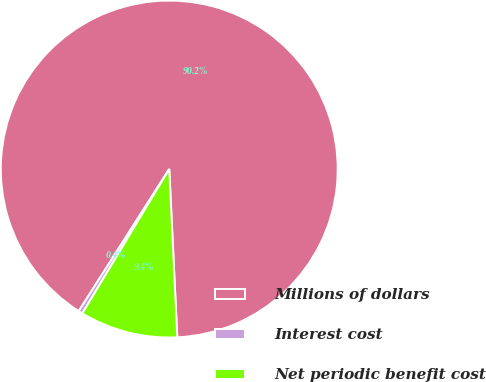<chart> <loc_0><loc_0><loc_500><loc_500><pie_chart><fcel>Millions of dollars<fcel>Interest cost<fcel>Net periodic benefit cost<nl><fcel>90.21%<fcel>0.4%<fcel>9.39%<nl></chart> 